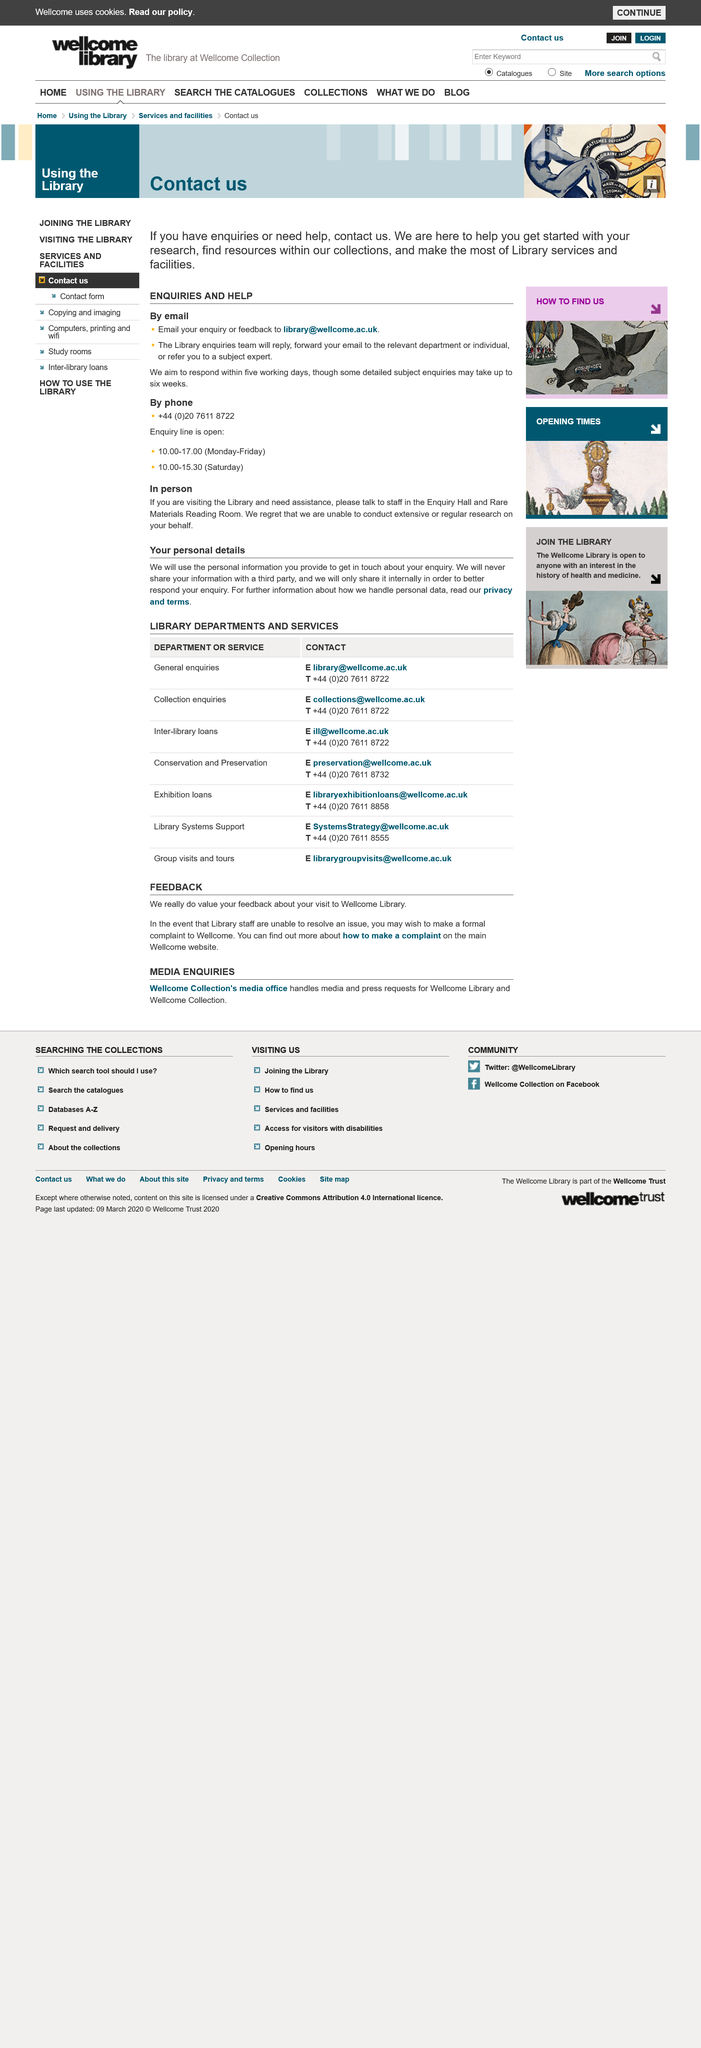Mention a couple of crucial points in this snapshot. At the library, assistance can be obtained by speaking with the staff in the Enquiry Hall and Rare Materials Reading Room. It is not a capability of the library to conduct extensive research on behalf of its users. 